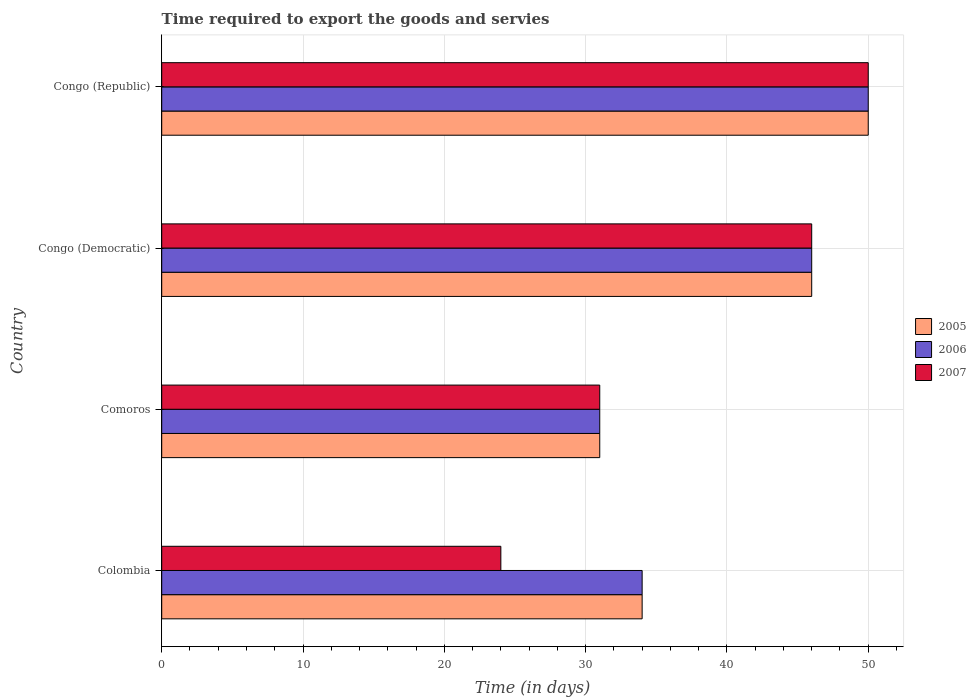How many different coloured bars are there?
Provide a short and direct response. 3. What is the label of the 4th group of bars from the top?
Your answer should be compact. Colombia. In how many cases, is the number of bars for a given country not equal to the number of legend labels?
Offer a terse response. 0. What is the number of days required to export the goods and services in 2006 in Congo (Republic)?
Give a very brief answer. 50. Across all countries, what is the maximum number of days required to export the goods and services in 2005?
Provide a short and direct response. 50. In which country was the number of days required to export the goods and services in 2005 maximum?
Your answer should be very brief. Congo (Republic). In which country was the number of days required to export the goods and services in 2005 minimum?
Ensure brevity in your answer.  Comoros. What is the total number of days required to export the goods and services in 2006 in the graph?
Offer a very short reply. 161. What is the average number of days required to export the goods and services in 2006 per country?
Keep it short and to the point. 40.25. In how many countries, is the number of days required to export the goods and services in 2007 greater than 12 days?
Give a very brief answer. 4. What is the ratio of the number of days required to export the goods and services in 2007 in Colombia to that in Congo (Republic)?
Ensure brevity in your answer.  0.48. Is the number of days required to export the goods and services in 2007 in Comoros less than that in Congo (Republic)?
Your answer should be compact. Yes. Is the difference between the number of days required to export the goods and services in 2005 in Comoros and Congo (Republic) greater than the difference between the number of days required to export the goods and services in 2006 in Comoros and Congo (Republic)?
Keep it short and to the point. No. In how many countries, is the number of days required to export the goods and services in 2007 greater than the average number of days required to export the goods and services in 2007 taken over all countries?
Offer a terse response. 2. Is the sum of the number of days required to export the goods and services in 2006 in Colombia and Comoros greater than the maximum number of days required to export the goods and services in 2007 across all countries?
Your answer should be very brief. Yes. Is it the case that in every country, the sum of the number of days required to export the goods and services in 2006 and number of days required to export the goods and services in 2007 is greater than the number of days required to export the goods and services in 2005?
Your response must be concise. Yes. Are all the bars in the graph horizontal?
Provide a succinct answer. Yes. How many countries are there in the graph?
Your answer should be compact. 4. Where does the legend appear in the graph?
Provide a short and direct response. Center right. How many legend labels are there?
Offer a terse response. 3. How are the legend labels stacked?
Offer a terse response. Vertical. What is the title of the graph?
Ensure brevity in your answer.  Time required to export the goods and servies. What is the label or title of the X-axis?
Keep it short and to the point. Time (in days). What is the Time (in days) in 2005 in Comoros?
Provide a short and direct response. 31. What is the Time (in days) in 2005 in Congo (Democratic)?
Offer a very short reply. 46. What is the Time (in days) of 2006 in Congo (Democratic)?
Provide a short and direct response. 46. What is the Time (in days) in 2007 in Congo (Democratic)?
Give a very brief answer. 46. Across all countries, what is the maximum Time (in days) in 2005?
Offer a very short reply. 50. Across all countries, what is the maximum Time (in days) of 2007?
Your answer should be very brief. 50. Across all countries, what is the minimum Time (in days) of 2005?
Make the answer very short. 31. Across all countries, what is the minimum Time (in days) in 2007?
Keep it short and to the point. 24. What is the total Time (in days) of 2005 in the graph?
Ensure brevity in your answer.  161. What is the total Time (in days) in 2006 in the graph?
Your response must be concise. 161. What is the total Time (in days) of 2007 in the graph?
Your answer should be compact. 151. What is the difference between the Time (in days) of 2006 in Colombia and that in Comoros?
Your answer should be very brief. 3. What is the difference between the Time (in days) in 2007 in Colombia and that in Comoros?
Make the answer very short. -7. What is the difference between the Time (in days) in 2005 in Colombia and that in Congo (Republic)?
Keep it short and to the point. -16. What is the difference between the Time (in days) of 2006 in Colombia and that in Congo (Republic)?
Provide a short and direct response. -16. What is the difference between the Time (in days) of 2005 in Comoros and that in Congo (Democratic)?
Give a very brief answer. -15. What is the difference between the Time (in days) in 2007 in Comoros and that in Congo (Democratic)?
Provide a short and direct response. -15. What is the difference between the Time (in days) of 2007 in Comoros and that in Congo (Republic)?
Provide a short and direct response. -19. What is the difference between the Time (in days) in 2007 in Congo (Democratic) and that in Congo (Republic)?
Provide a succinct answer. -4. What is the difference between the Time (in days) in 2005 in Colombia and the Time (in days) in 2006 in Comoros?
Keep it short and to the point. 3. What is the difference between the Time (in days) in 2005 in Colombia and the Time (in days) in 2007 in Comoros?
Make the answer very short. 3. What is the difference between the Time (in days) of 2006 in Colombia and the Time (in days) of 2007 in Comoros?
Your answer should be very brief. 3. What is the difference between the Time (in days) of 2006 in Colombia and the Time (in days) of 2007 in Congo (Democratic)?
Keep it short and to the point. -12. What is the difference between the Time (in days) of 2005 in Colombia and the Time (in days) of 2006 in Congo (Republic)?
Make the answer very short. -16. What is the difference between the Time (in days) in 2006 in Comoros and the Time (in days) in 2007 in Congo (Democratic)?
Offer a very short reply. -15. What is the difference between the Time (in days) in 2005 in Comoros and the Time (in days) in 2006 in Congo (Republic)?
Your response must be concise. -19. What is the difference between the Time (in days) of 2006 in Comoros and the Time (in days) of 2007 in Congo (Republic)?
Give a very brief answer. -19. What is the difference between the Time (in days) in 2005 in Congo (Democratic) and the Time (in days) in 2006 in Congo (Republic)?
Provide a succinct answer. -4. What is the difference between the Time (in days) of 2005 in Congo (Democratic) and the Time (in days) of 2007 in Congo (Republic)?
Your answer should be compact. -4. What is the difference between the Time (in days) in 2006 in Congo (Democratic) and the Time (in days) in 2007 in Congo (Republic)?
Your answer should be compact. -4. What is the average Time (in days) in 2005 per country?
Offer a very short reply. 40.25. What is the average Time (in days) of 2006 per country?
Ensure brevity in your answer.  40.25. What is the average Time (in days) in 2007 per country?
Make the answer very short. 37.75. What is the difference between the Time (in days) of 2005 and Time (in days) of 2006 in Colombia?
Provide a succinct answer. 0. What is the difference between the Time (in days) in 2006 and Time (in days) in 2007 in Congo (Democratic)?
Offer a terse response. 0. What is the difference between the Time (in days) of 2005 and Time (in days) of 2006 in Congo (Republic)?
Your answer should be very brief. 0. What is the ratio of the Time (in days) in 2005 in Colombia to that in Comoros?
Make the answer very short. 1.1. What is the ratio of the Time (in days) in 2006 in Colombia to that in Comoros?
Your response must be concise. 1.1. What is the ratio of the Time (in days) in 2007 in Colombia to that in Comoros?
Keep it short and to the point. 0.77. What is the ratio of the Time (in days) of 2005 in Colombia to that in Congo (Democratic)?
Ensure brevity in your answer.  0.74. What is the ratio of the Time (in days) in 2006 in Colombia to that in Congo (Democratic)?
Keep it short and to the point. 0.74. What is the ratio of the Time (in days) of 2007 in Colombia to that in Congo (Democratic)?
Give a very brief answer. 0.52. What is the ratio of the Time (in days) of 2005 in Colombia to that in Congo (Republic)?
Make the answer very short. 0.68. What is the ratio of the Time (in days) of 2006 in Colombia to that in Congo (Republic)?
Keep it short and to the point. 0.68. What is the ratio of the Time (in days) of 2007 in Colombia to that in Congo (Republic)?
Offer a very short reply. 0.48. What is the ratio of the Time (in days) of 2005 in Comoros to that in Congo (Democratic)?
Provide a succinct answer. 0.67. What is the ratio of the Time (in days) of 2006 in Comoros to that in Congo (Democratic)?
Provide a short and direct response. 0.67. What is the ratio of the Time (in days) in 2007 in Comoros to that in Congo (Democratic)?
Provide a short and direct response. 0.67. What is the ratio of the Time (in days) of 2005 in Comoros to that in Congo (Republic)?
Your response must be concise. 0.62. What is the ratio of the Time (in days) in 2006 in Comoros to that in Congo (Republic)?
Your answer should be very brief. 0.62. What is the ratio of the Time (in days) in 2007 in Comoros to that in Congo (Republic)?
Offer a very short reply. 0.62. What is the ratio of the Time (in days) in 2006 in Congo (Democratic) to that in Congo (Republic)?
Offer a very short reply. 0.92. What is the difference between the highest and the second highest Time (in days) in 2005?
Offer a very short reply. 4. What is the difference between the highest and the second highest Time (in days) in 2007?
Your answer should be very brief. 4. What is the difference between the highest and the lowest Time (in days) in 2005?
Your answer should be very brief. 19. What is the difference between the highest and the lowest Time (in days) in 2006?
Your answer should be compact. 19. 